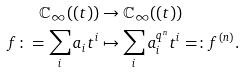<formula> <loc_0><loc_0><loc_500><loc_500>\mathbb { C } _ { \infty } ( ( t ) ) & \rightarrow \mathbb { C } _ { \infty } ( ( t ) ) \\ f \colon = \sum _ { i } a _ { i } t ^ { i } & \mapsto \sum _ { i } a _ { i } ^ { q ^ { n } } t ^ { i } = \colon f ^ { ( n ) } .</formula> 